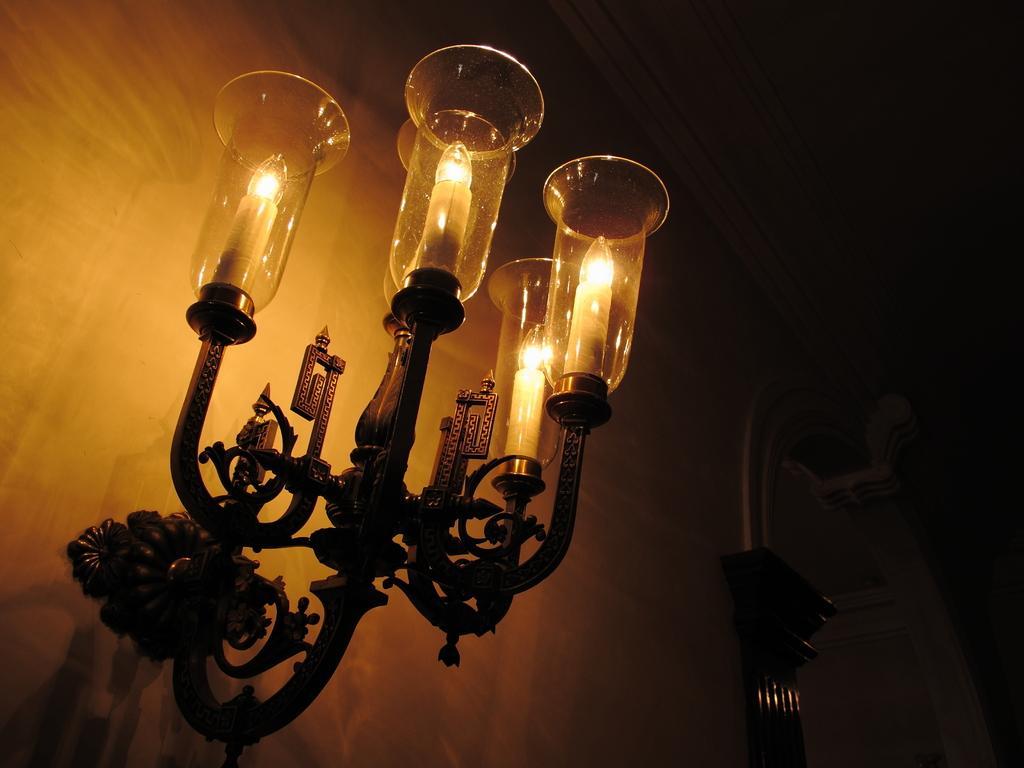Can you describe this image briefly? In this image I can see on the left side there are lamps. 